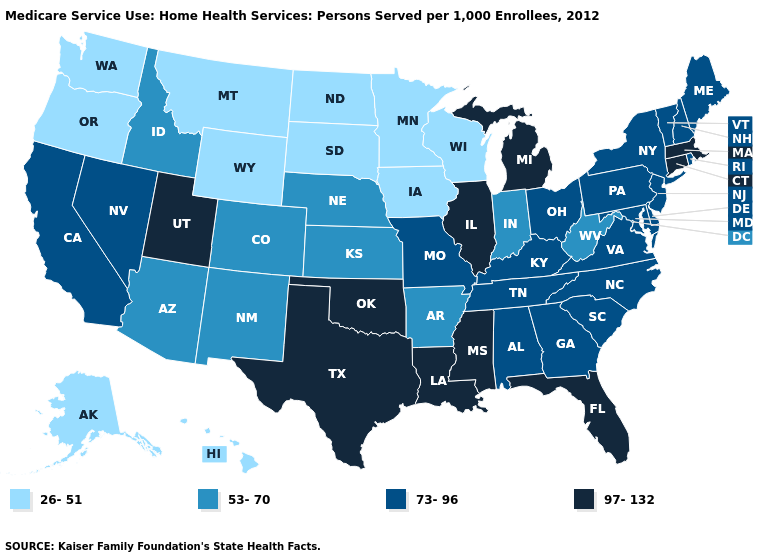What is the value of Minnesota?
Concise answer only. 26-51. Does Michigan have a higher value than Iowa?
Keep it brief. Yes. What is the lowest value in the South?
Give a very brief answer. 53-70. Among the states that border Oklahoma , does Texas have the lowest value?
Be succinct. No. Which states have the highest value in the USA?
Give a very brief answer. Connecticut, Florida, Illinois, Louisiana, Massachusetts, Michigan, Mississippi, Oklahoma, Texas, Utah. Among the states that border Rhode Island , which have the lowest value?
Give a very brief answer. Connecticut, Massachusetts. Does Nebraska have the highest value in the MidWest?
Be succinct. No. What is the value of Maryland?
Give a very brief answer. 73-96. Does Wyoming have the lowest value in the USA?
Keep it brief. Yes. Which states have the lowest value in the USA?
Answer briefly. Alaska, Hawaii, Iowa, Minnesota, Montana, North Dakota, Oregon, South Dakota, Washington, Wisconsin, Wyoming. Does Iowa have the lowest value in the USA?
Quick response, please. Yes. What is the value of Delaware?
Keep it brief. 73-96. Name the states that have a value in the range 53-70?
Be succinct. Arizona, Arkansas, Colorado, Idaho, Indiana, Kansas, Nebraska, New Mexico, West Virginia. Name the states that have a value in the range 26-51?
Concise answer only. Alaska, Hawaii, Iowa, Minnesota, Montana, North Dakota, Oregon, South Dakota, Washington, Wisconsin, Wyoming. What is the lowest value in states that border North Carolina?
Concise answer only. 73-96. 